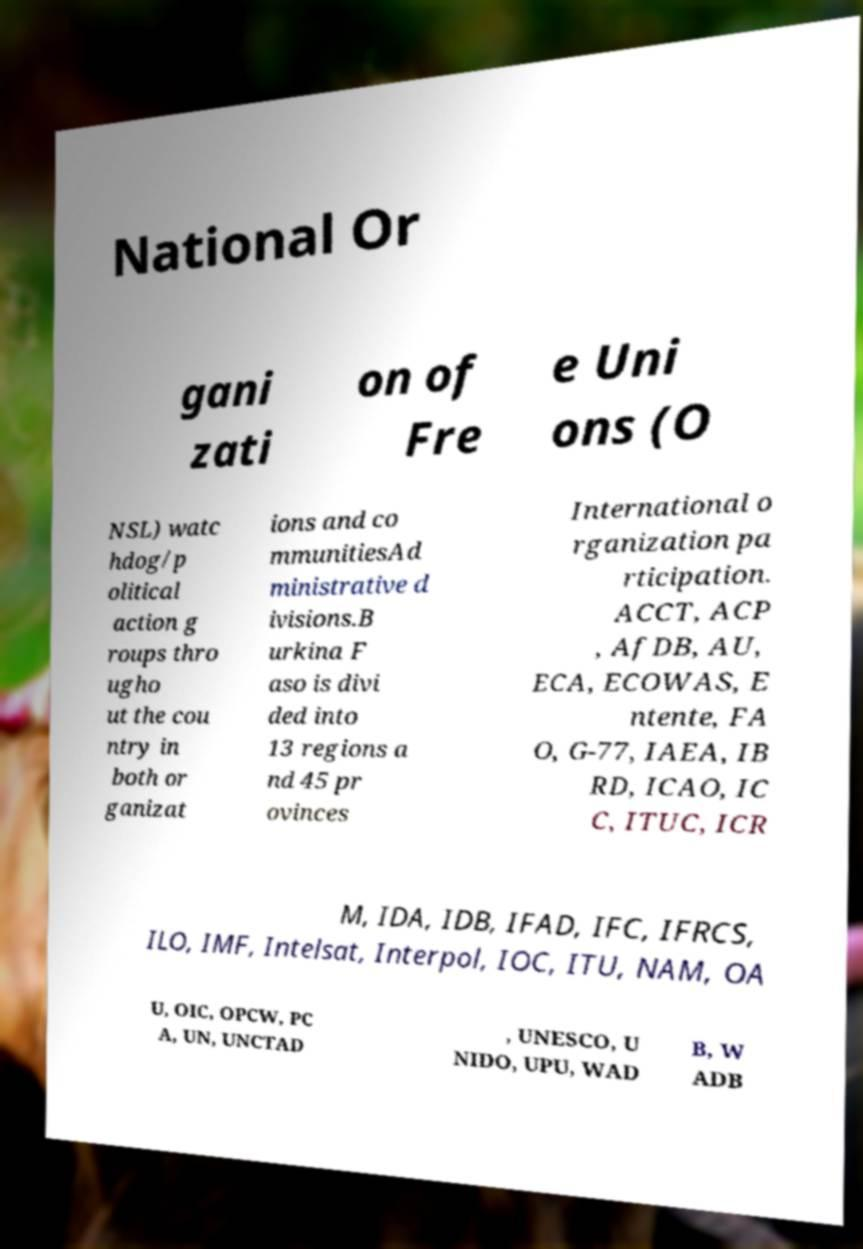Could you assist in decoding the text presented in this image and type it out clearly? National Or gani zati on of Fre e Uni ons (O NSL) watc hdog/p olitical action g roups thro ugho ut the cou ntry in both or ganizat ions and co mmunitiesAd ministrative d ivisions.B urkina F aso is divi ded into 13 regions a nd 45 pr ovinces International o rganization pa rticipation. ACCT, ACP , AfDB, AU, ECA, ECOWAS, E ntente, FA O, G-77, IAEA, IB RD, ICAO, IC C, ITUC, ICR M, IDA, IDB, IFAD, IFC, IFRCS, ILO, IMF, Intelsat, Interpol, IOC, ITU, NAM, OA U, OIC, OPCW, PC A, UN, UNCTAD , UNESCO, U NIDO, UPU, WAD B, W ADB 